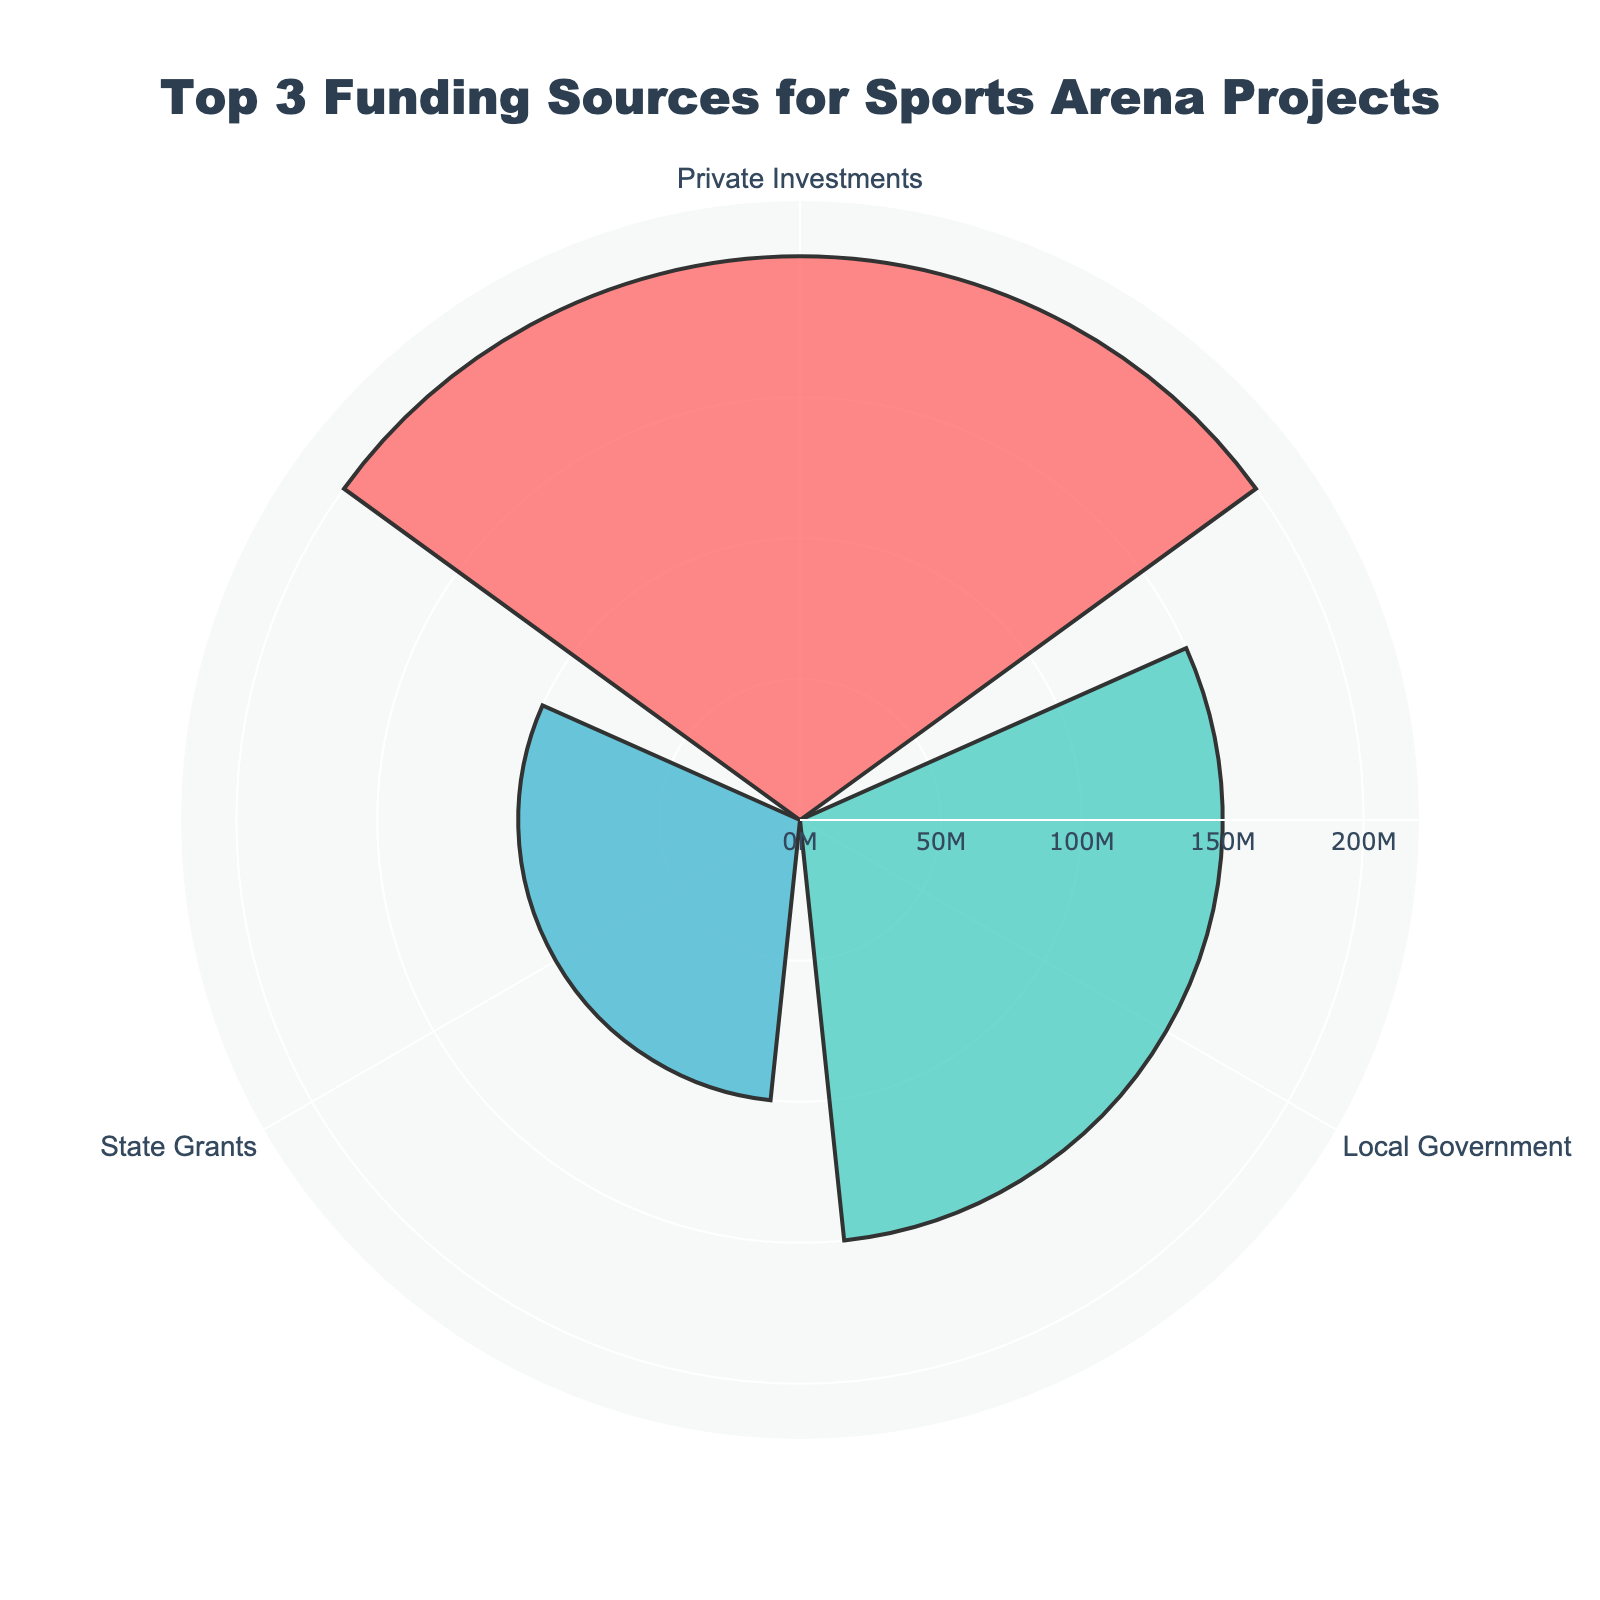What is the title of the figure? The title is usually placed at the top of the figure in a larger font size. Here, the title reads "Top 3 Funding Sources for Sports Arena Projects".
Answer: Top 3 Funding Sources for Sports Arena Projects Which funding source received the highest allocation? The funding source with the longest bar in the rose chart represents the highest allocation. In this chart, "Private Investments" has the longest bar.
Answer: Private Investments What is the total amount of funding allocated by the top three sources? To find the total, add the amounts for the top three sources: 200 million (Private Investments) + 150 million (Local Government) + 100 million (State Grants). This gives 450 million.
Answer: 450 million How does the funding from the local government compare to the state grants? Look at the lengths of the bars for "Local Government" and "State Grants". The local government bar is longer. Specifically, the funding from the local government is 150 million, whereas state grants are 100 million.
Answer: Local Government has 50 million more funding than State Grants What are the color representations for each funding source in the chart? In the rose chart, each bar is represented by a distinct color. "Local Government" is colored red (#FF6B6B), "State Grants" is green (#4ECDC4), and "Private Investments" is blue (#45B7D1).
Answer: Local Government - red, State Grants - green, Private Investments - blue How much more funding did Private Investments receive compared to State Grants? Subtract the amount for State Grants (100 million) from the amount for Private Investments (200 million): 200 - 100 = 100 million.
Answer: 100 million Which funding source contributes the least among the top three? The funding source with the shortest bar in the rose chart among the top three is "State Grants" with 100 million.
Answer: State Grants What is the difference in funding between the largest and smallest funding sources in the top three? The largest funding source is Private Investments (200 million) and the smallest is State Grants (100 million). The difference is 200 - 100 = 100 million.
Answer: 100 million 